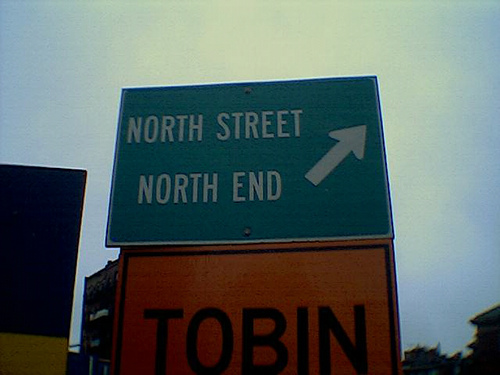<image>What is the history of the sign in this photo? The history of the sign in the photo is unknown. Where exactly is Tobin? I don't know exactly where Tobin is. It can be located on North Street or North end of North Street. Where exactly is Tobin? It is ambiguous where exactly Tobin is. It can be North Street, North End, or on the sign. What is the history of the sign in this photo? I don't know the history of the sign in the photo. It can be used to give directions or it can be pointing to a location. 